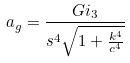Convert formula to latex. <formula><loc_0><loc_0><loc_500><loc_500>a _ { g } = \frac { G i _ { 3 } } { s ^ { 4 } \sqrt { 1 + \frac { k ^ { 4 } } { c ^ { 4 } } } }</formula> 